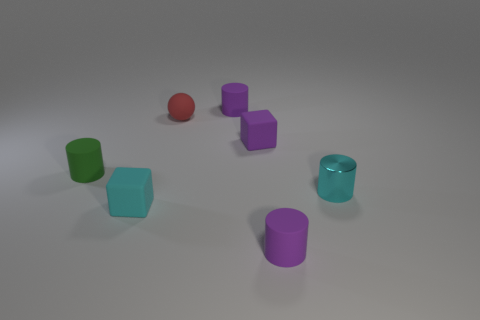What number of tiny things have the same material as the green cylinder? Upon examining the image closely, I have identified a total of five objects that share the matte-like material characteristic of the green cylinder. These include two purple cylinders, one green cube, one aqua cube, and one red sphere. The diffused lighting in the scene doesn't reflect off any of these objects, indicating their similar non-glossy surfaces, unlike the remaining shiny cylinder. 